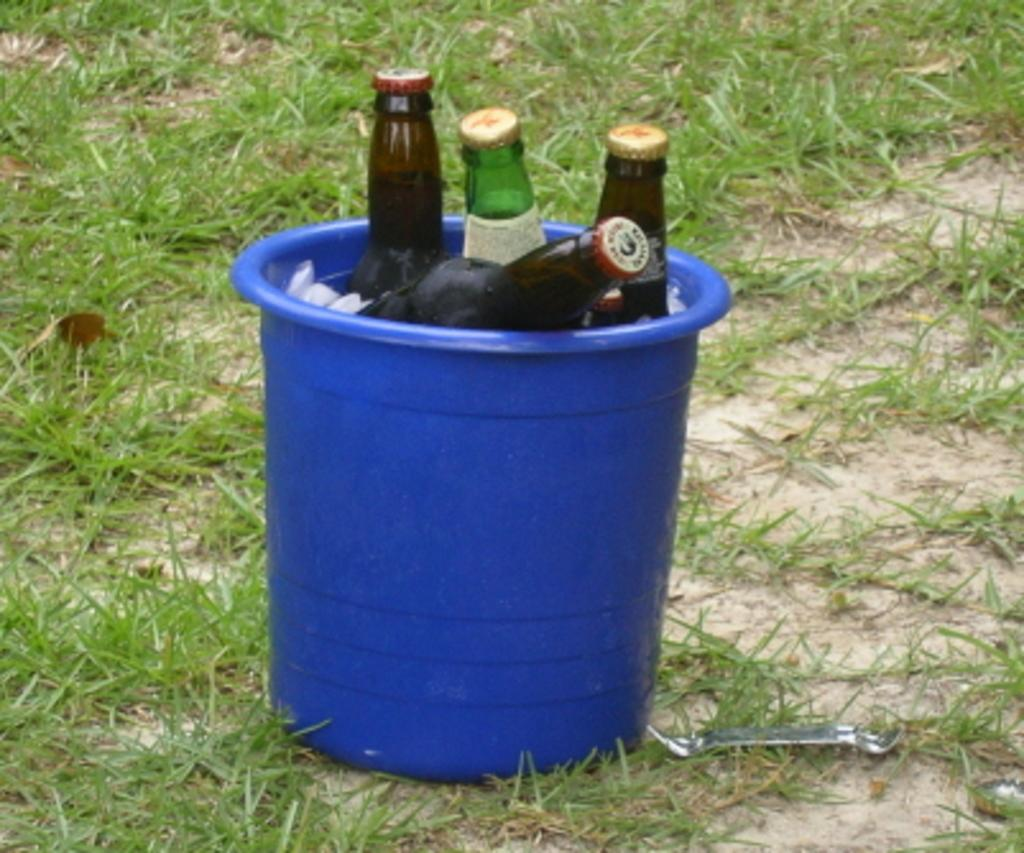What object is present in the image that can hold items? There is a bucket in the image that can hold items. What is inside the bucket in the image? The bucket contains bottles. What type of natural environment is visible in the image? There is grass in the image, indicating a natural environment. What type of soup is being prepared by the servant in the image? There is no soup or servant present in the image; it only features a bucket containing bottles and grass. 